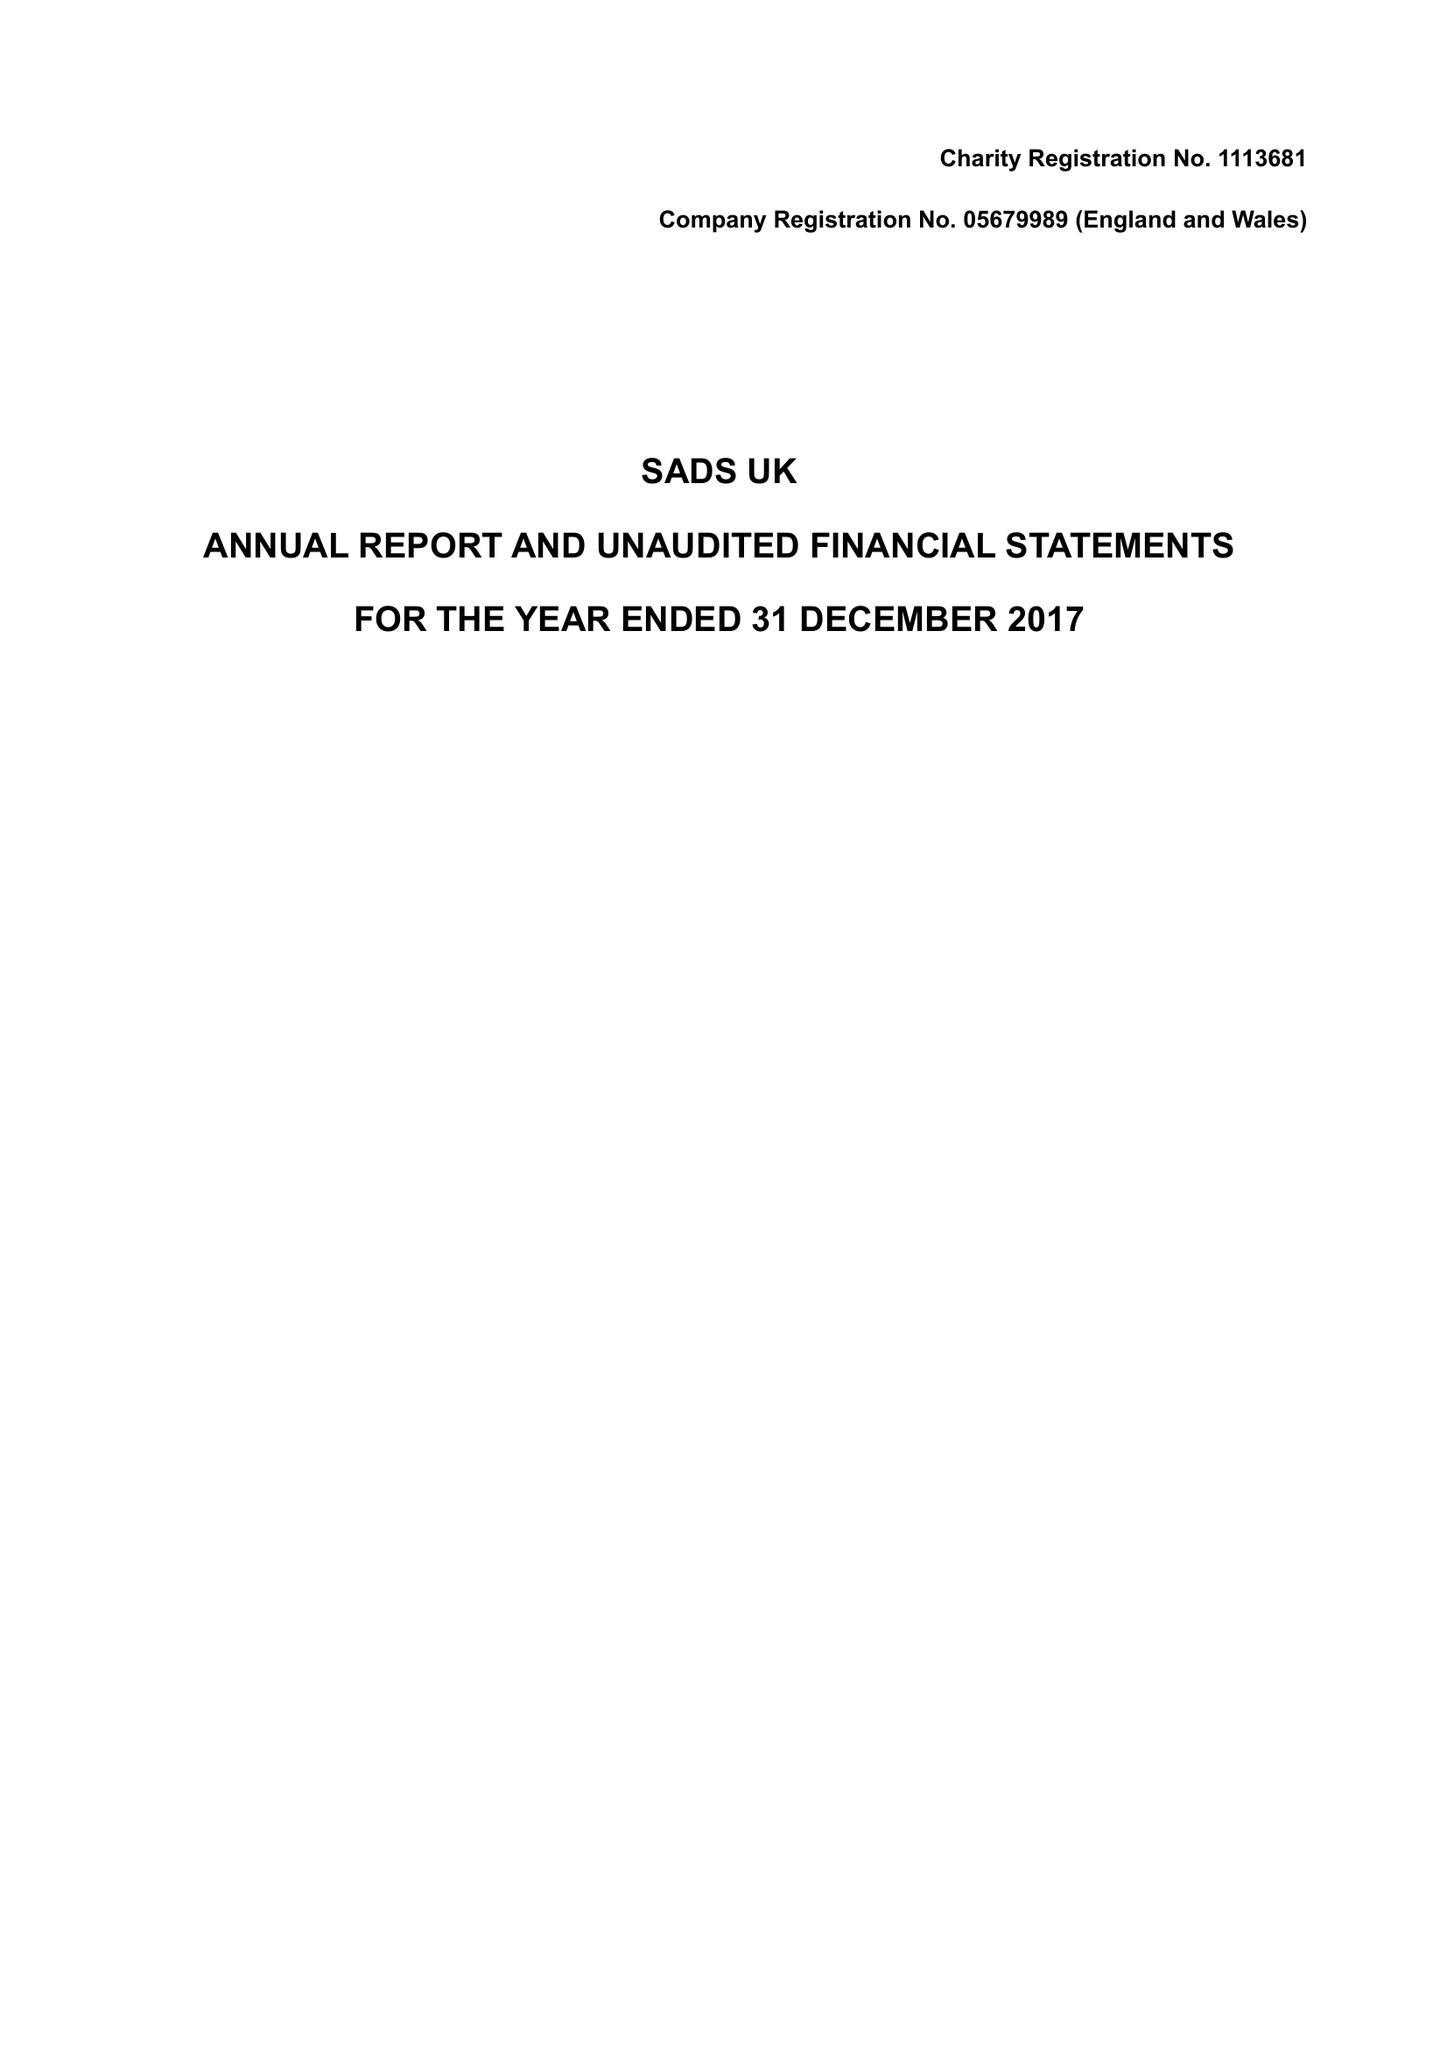What is the value for the address__post_town?
Answer the question using a single word or phrase. BRENTWOOD 